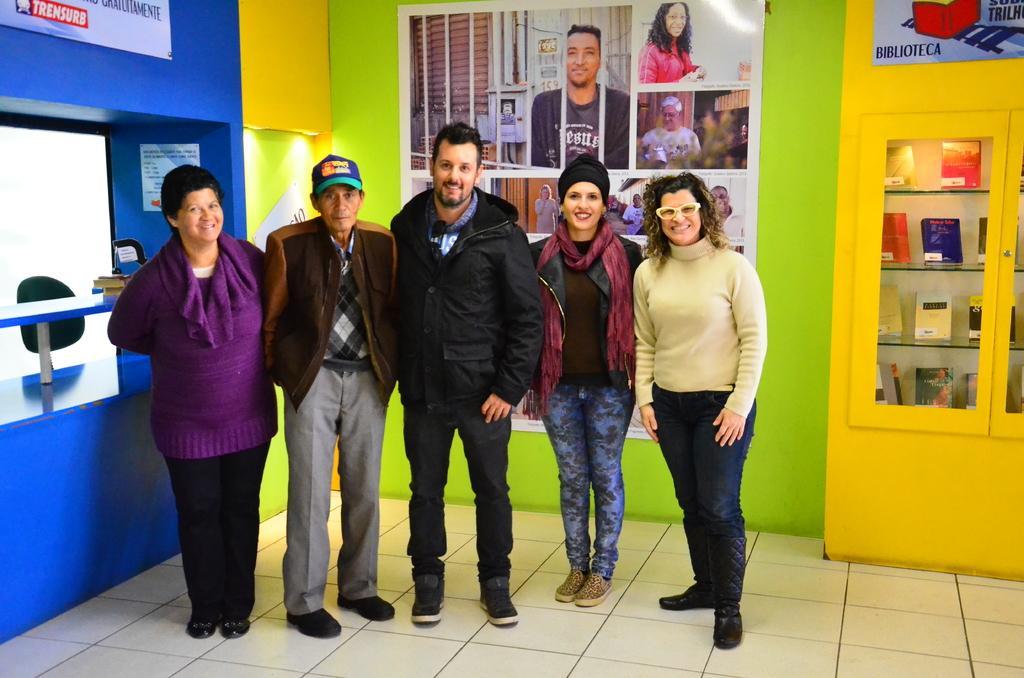Describe this image in one or two sentences. In this image, I can see five persons standing on the floor and smiling. On the right side of the image, there are books, which are kept in a cupboard. In the background, I can see the posts attached to the wall. On the left side of the image, there are few objects. 